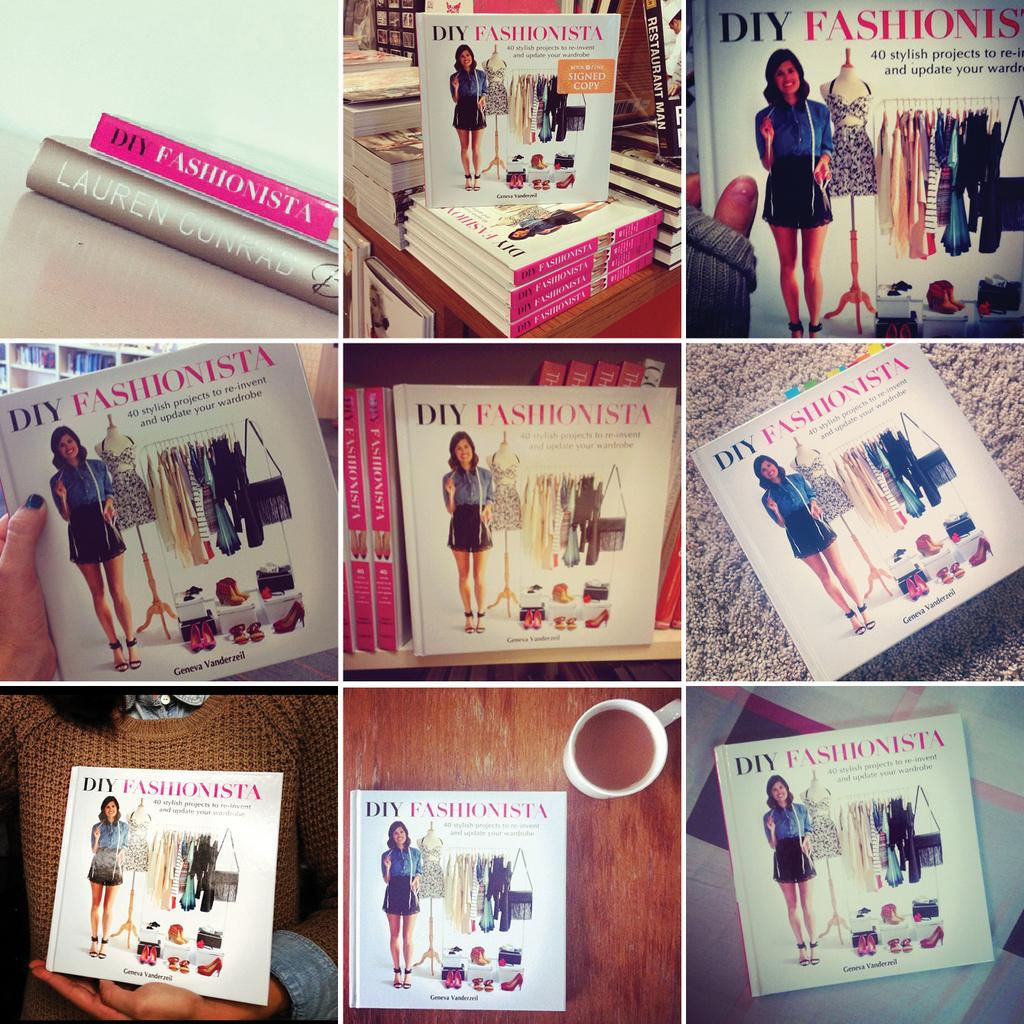<image>
Create a compact narrative representing the image presented. diy fashionista books displayed at the book store 